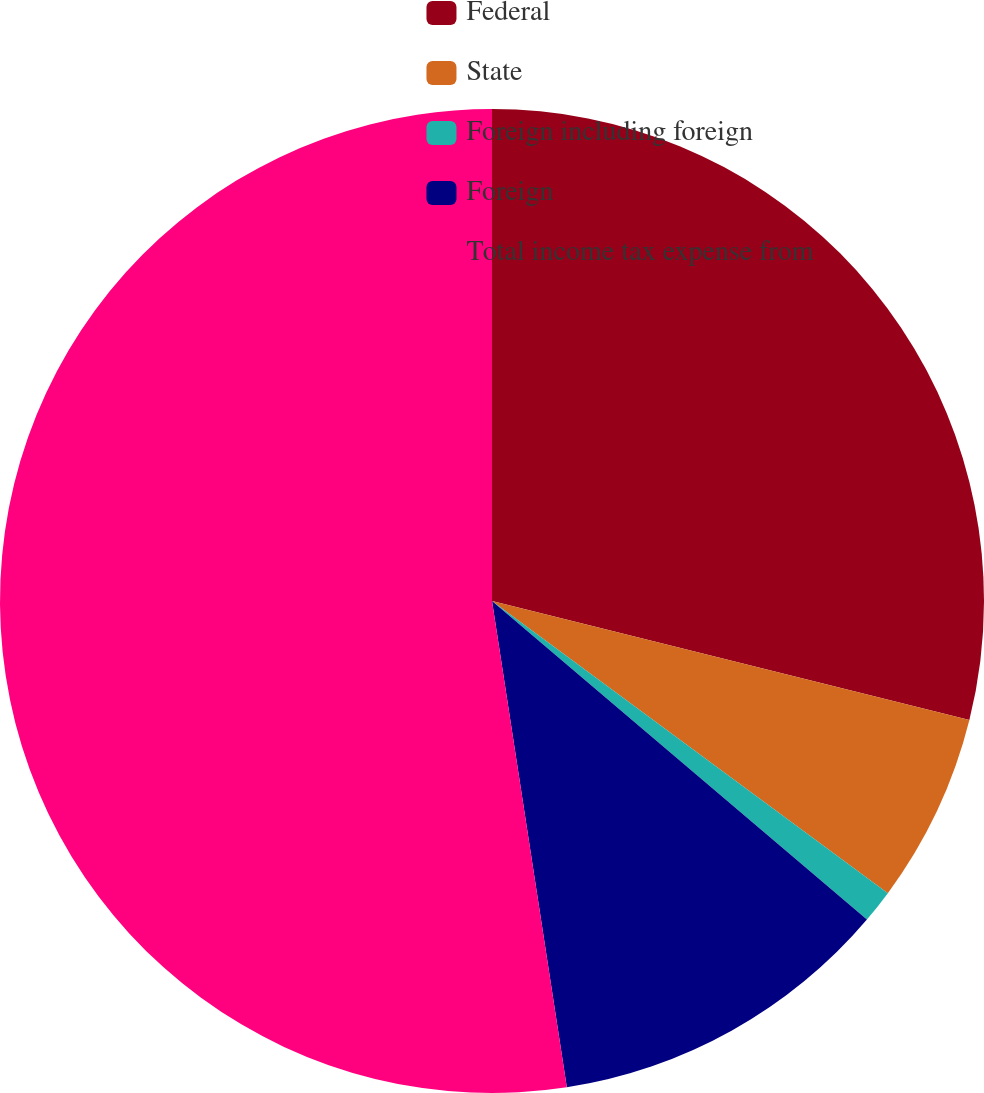Convert chart. <chart><loc_0><loc_0><loc_500><loc_500><pie_chart><fcel>Federal<fcel>State<fcel>Foreign including foreign<fcel>Foreign<fcel>Total income tax expense from<nl><fcel>28.89%<fcel>6.23%<fcel>1.09%<fcel>11.36%<fcel>52.43%<nl></chart> 